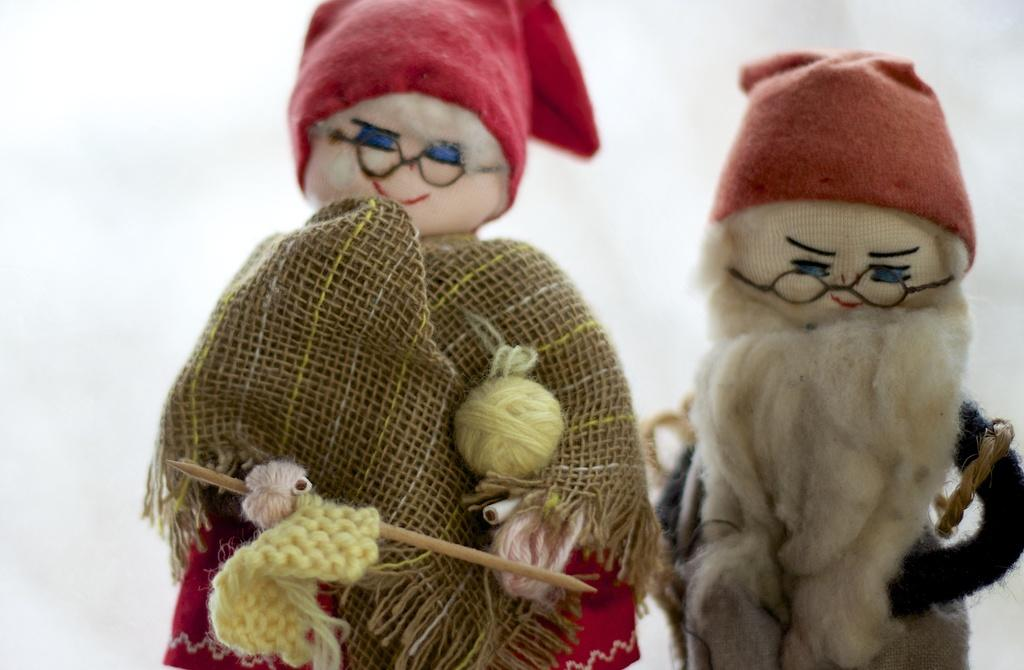How many dolls are present in the image? There are two dolls in the image. What is the doll on the left side holding? The doll on the left side is holding a weaving stick and a woolen thread. What is the color of the background in the image? The background of the image is white in color. What type of plot is being discussed by the secretary in the image? There is no secretary present in the image, and therefore no discussion about a plot can be observed. 